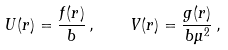<formula> <loc_0><loc_0><loc_500><loc_500>U ( r ) = \frac { f ( r ) } { b } \, , \quad V ( r ) = \frac { g ( r ) } { b \mu ^ { 2 } } \, ,</formula> 